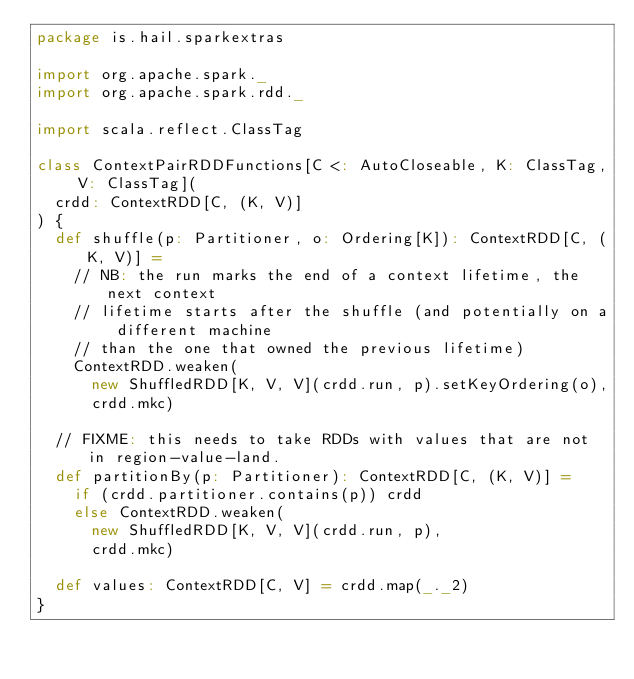<code> <loc_0><loc_0><loc_500><loc_500><_Scala_>package is.hail.sparkextras

import org.apache.spark._
import org.apache.spark.rdd._

import scala.reflect.ClassTag

class ContextPairRDDFunctions[C <: AutoCloseable, K: ClassTag, V: ClassTag](
  crdd: ContextRDD[C, (K, V)]
) {
  def shuffle(p: Partitioner, o: Ordering[K]): ContextRDD[C, (K, V)] =
    // NB: the run marks the end of a context lifetime, the next context
    // lifetime starts after the shuffle (and potentially on a different machine
    // than the one that owned the previous lifetime)
    ContextRDD.weaken(
      new ShuffledRDD[K, V, V](crdd.run, p).setKeyOrdering(o),
      crdd.mkc)

  // FIXME: this needs to take RDDs with values that are not in region-value-land.
  def partitionBy(p: Partitioner): ContextRDD[C, (K, V)] =
    if (crdd.partitioner.contains(p)) crdd
    else ContextRDD.weaken(
      new ShuffledRDD[K, V, V](crdd.run, p),
      crdd.mkc)

  def values: ContextRDD[C, V] = crdd.map(_._2)
}
</code> 